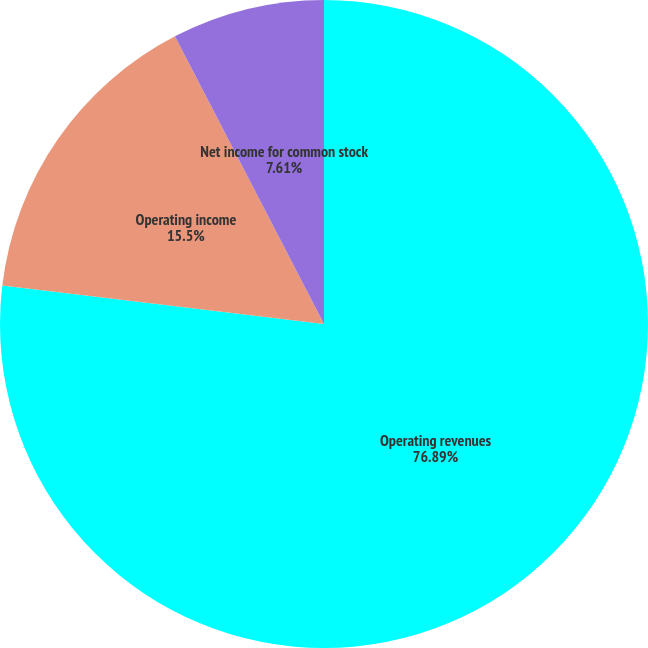Convert chart. <chart><loc_0><loc_0><loc_500><loc_500><pie_chart><fcel>Operating revenues<fcel>Operating income<fcel>Net income for common stock<nl><fcel>76.89%<fcel>15.5%<fcel>7.61%<nl></chart> 